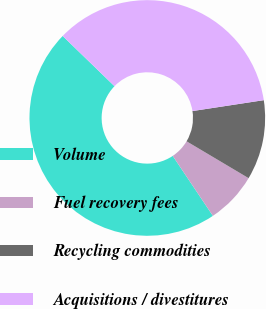<chart> <loc_0><loc_0><loc_500><loc_500><pie_chart><fcel>Volume<fcel>Fuel recovery fees<fcel>Recycling commodities<fcel>Acquisitions / divestitures<nl><fcel>46.64%<fcel>7.07%<fcel>10.95%<fcel>35.34%<nl></chart> 